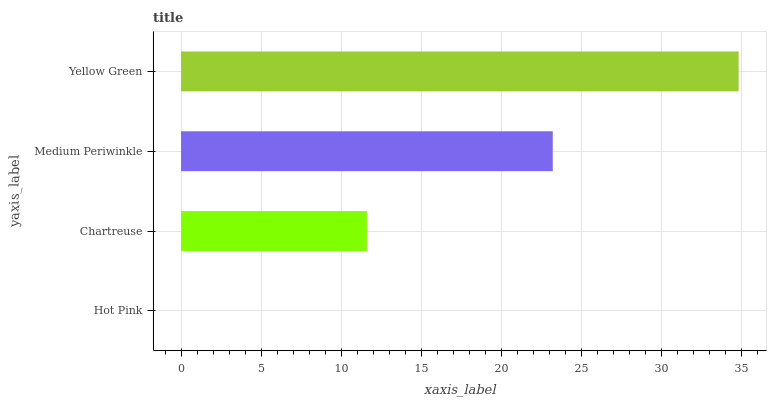Is Hot Pink the minimum?
Answer yes or no. Yes. Is Yellow Green the maximum?
Answer yes or no. Yes. Is Chartreuse the minimum?
Answer yes or no. No. Is Chartreuse the maximum?
Answer yes or no. No. Is Chartreuse greater than Hot Pink?
Answer yes or no. Yes. Is Hot Pink less than Chartreuse?
Answer yes or no. Yes. Is Hot Pink greater than Chartreuse?
Answer yes or no. No. Is Chartreuse less than Hot Pink?
Answer yes or no. No. Is Medium Periwinkle the high median?
Answer yes or no. Yes. Is Chartreuse the low median?
Answer yes or no. Yes. Is Chartreuse the high median?
Answer yes or no. No. Is Yellow Green the low median?
Answer yes or no. No. 